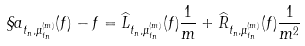Convert formula to latex. <formula><loc_0><loc_0><loc_500><loc_500>\S a _ { t _ { n } , \mu _ { t _ { n } } ^ { ( m ) } } ( f ) - f = \widehat { L } _ { t _ { n } , \mu _ { t _ { n } } ^ { ( m ) } } ( f ) \frac { 1 } { m } + \widehat { R } _ { t _ { n } , \mu _ { t _ { n } } ^ { ( m ) } } ( f ) \frac { 1 } { m ^ { 2 } }</formula> 